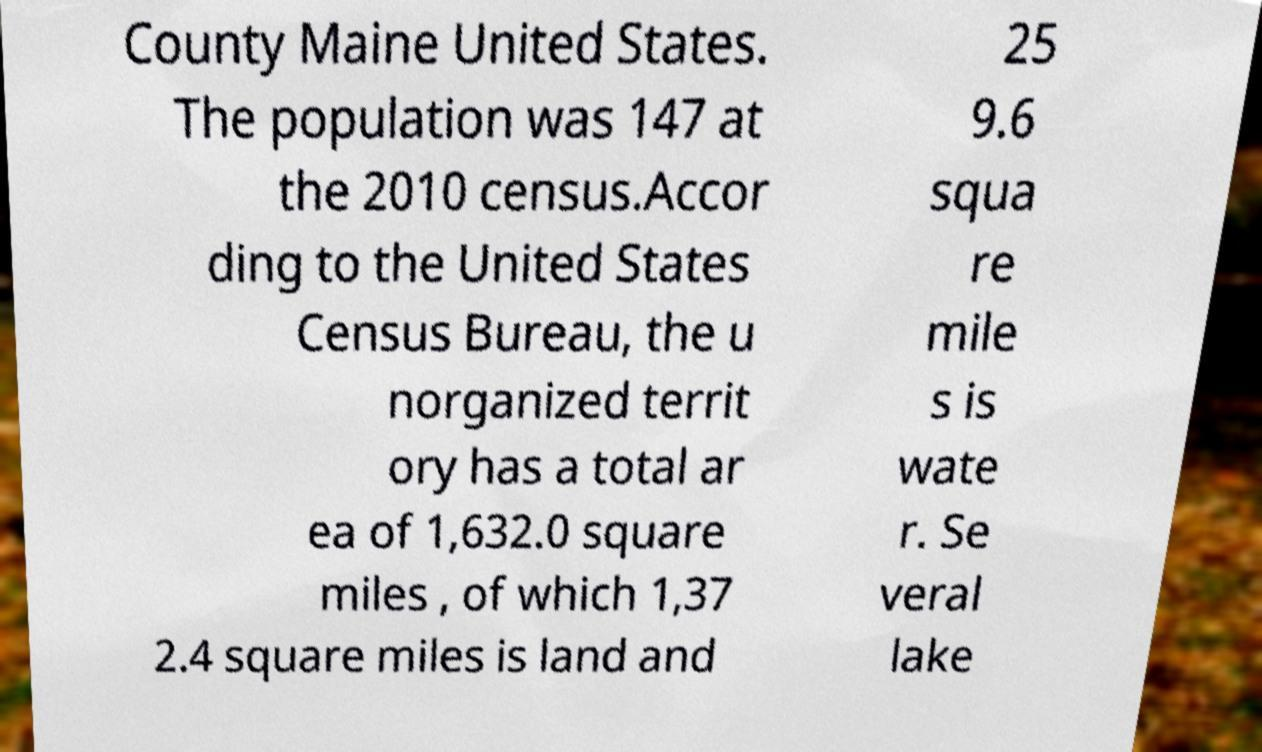Could you extract and type out the text from this image? County Maine United States. The population was 147 at the 2010 census.Accor ding to the United States Census Bureau, the u norganized territ ory has a total ar ea of 1,632.0 square miles , of which 1,37 2.4 square miles is land and 25 9.6 squa re mile s is wate r. Se veral lake 